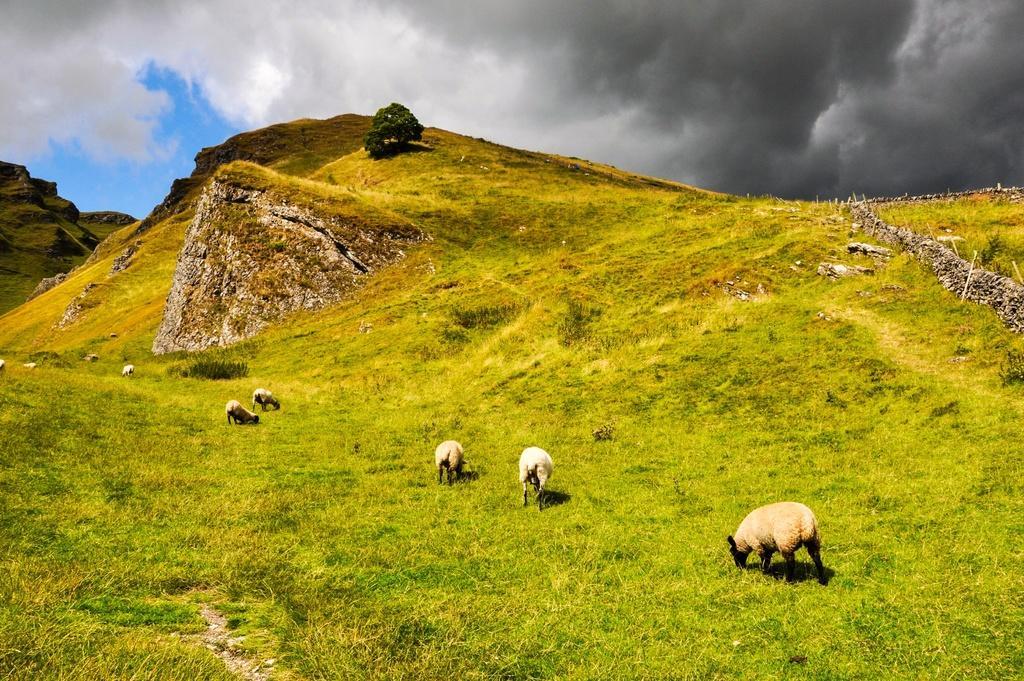Please provide a concise description of this image. In the picture I can see sheep are standing on the ground. In the background I can see the grass, hills, a tree and the sky. 